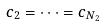Convert formula to latex. <formula><loc_0><loc_0><loc_500><loc_500>c _ { 2 } = \dots = c _ { N _ { 2 } }</formula> 